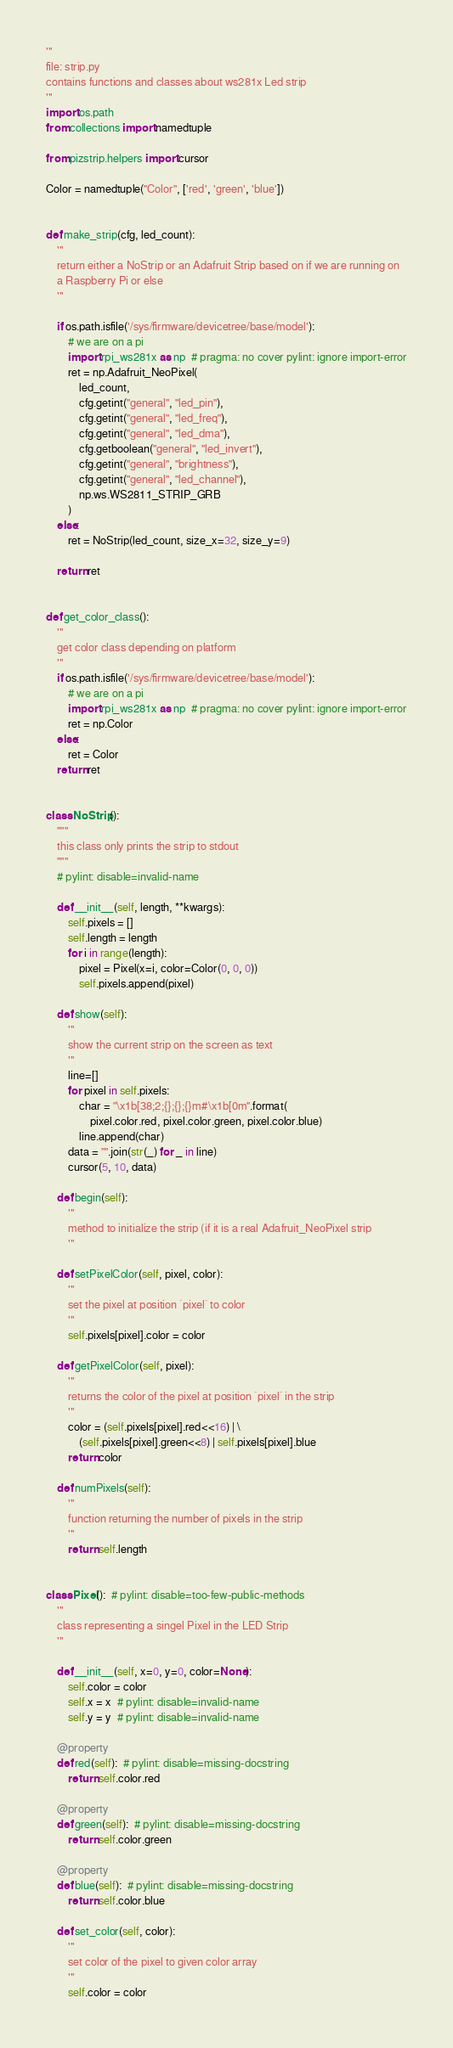Convert code to text. <code><loc_0><loc_0><loc_500><loc_500><_Python_>'''
file: strip.py
contains functions and classes about ws281x Led strip
'''
import os.path
from collections import namedtuple

from pizstrip.helpers import cursor

Color = namedtuple("Color", ['red', 'green', 'blue'])


def make_strip(cfg, led_count):
    '''
    return either a NoStrip or an Adafruit Strip based on if we are running on
    a Raspberry Pi or else
    '''

    if os.path.isfile('/sys/firmware/devicetree/base/model'):
        # we are on a pi
        import rpi_ws281x as np  # pragma: no cover pylint: ignore import-error
        ret = np.Adafruit_NeoPixel(
            led_count,
            cfg.getint("general", "led_pin"),
            cfg.getint("general", "led_freq"),
            cfg.getint("general", "led_dma"),
            cfg.getboolean("general", "led_invert"),
            cfg.getint("general", "brightness"),
            cfg.getint("general", "led_channel"),
            np.ws.WS2811_STRIP_GRB
        )
    else:
        ret = NoStrip(led_count, size_x=32, size_y=9)

    return ret


def get_color_class():
    '''
    get color class depending on platform
    '''
    if os.path.isfile('/sys/firmware/devicetree/base/model'):
        # we are on a pi
        import rpi_ws281x as np  # pragma: no cover pylint: ignore import-error
        ret = np.Color
    else:
        ret = Color
    return ret


class NoStrip():
    """
    this class only prints the strip to stdout
    """
    # pylint: disable=invalid-name

    def __init__(self, length, **kwargs):
        self.pixels = []
        self.length = length
        for i in range(length):
            pixel = Pixel(x=i, color=Color(0, 0, 0))
            self.pixels.append(pixel)

    def show(self):
        '''
        show the current strip on the screen as text
        '''
        line=[]
        for pixel in self.pixels:
            char = "\x1b[38;2;{};{};{}m#\x1b[0m".format(
                pixel.color.red, pixel.color.green, pixel.color.blue)
            line.append(char)
        data = "".join(str(_) for _ in line)
        cursor(5, 10, data)

    def begin(self):
        '''
        method to initialize the strip (if it is a real Adafruit_NeoPixel strip
        '''

    def setPixelColor(self, pixel, color):
        '''
        set the pixel at position `pixel` to color
        '''
        self.pixels[pixel].color = color

    def getPixelColor(self, pixel):
        '''
        returns the color of the pixel at position `pixel` in the strip
        '''
        color = (self.pixels[pixel].red<<16) | \
            (self.pixels[pixel].green<<8) | self.pixels[pixel].blue
        return color

    def numPixels(self):
        '''
        function returning the number of pixels in the strip
        '''
        return self.length


class Pixel():  # pylint: disable=too-few-public-methods
    '''
    class representing a singel Pixel in the LED Strip
    '''

    def __init__(self, x=0, y=0, color=None):
        self.color = color
        self.x = x  # pylint: disable=invalid-name
        self.y = y  # pylint: disable=invalid-name

    @property
    def red(self):  # pylint: disable=missing-docstring
        return self.color.red

    @property
    def green(self):  # pylint: disable=missing-docstring
        return self.color.green

    @property
    def blue(self):  # pylint: disable=missing-docstring
        return self.color.blue

    def set_color(self, color):
        '''
        set color of the pixel to given color array
        '''
        self.color = color
</code> 